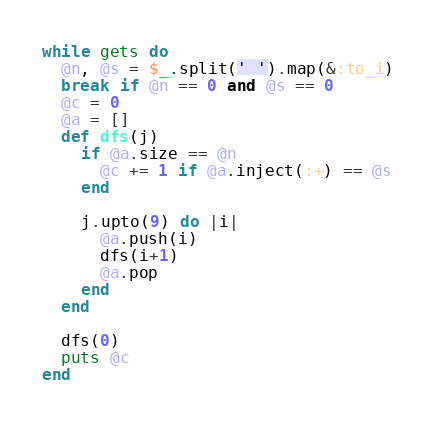<code> <loc_0><loc_0><loc_500><loc_500><_Ruby_>while gets do
  @n, @s = $_.split(' ').map(&:to_i)
  break if @n == 0 and @s == 0
  @c = 0
  @a = []
  def dfs(j)
    if @a.size == @n
      @c += 1 if @a.inject(:+) == @s
    end

    j.upto(9) do |i|
      @a.push(i)
      dfs(i+1)
      @a.pop
    end
  end

  dfs(0)
  puts @c
end</code> 